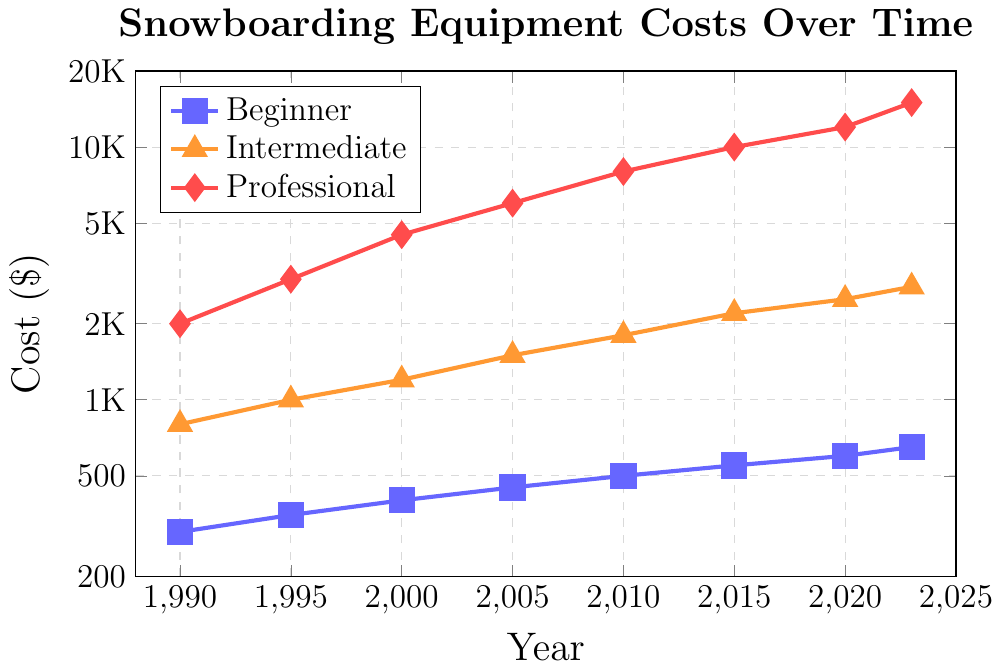What year did professional-grade snowboarding equipment costs first exceed $10,000? Observing the red (Professional) line, the cost first surpasses $10,000 at the point marked "2015".
Answer: 2015 Which level of equipment saw the greatest percentage increase from 1990 to 2023? Calculate the percentage increase for each category:
- Beginner: ((650 - 300) / 300) * 100 = 116.67%
- Intermediate: ((2800 - 800) / 800) * 100 = 250%
- Professional: ((15000 - 2000) / 2000) * 100 = 650%
The professional level saw the greatest percentage increase.
Answer: Professional At which year did the cost of intermediate equipment approximately double compared to its cost in 1990? The 1990 cost for intermediate equipment is $800. Doubling this is $1600. The orange (Intermediate) line reaches $1800 in 2010, which is closest to doubling the 1990 cost.
Answer: 2010 What is the approximate cost difference between beginner and professional equipment in 2023? At 2023, the red (Professional) line is at $15,000 and the blue (Beginner) line is at $650. The difference is $15,000 - $650.
Answer: $14,350 Between which years did intermediate equipment costs see the largest single period increase, and what was the amount of this increase? Observe the orange (Intermediate) line for the largest vertical jump between points:
- 1990 to 1995: $1000 - $800 = $200
- 1995 to 2000: $1200 - $1000 = $200
- 2000 to 2005: $1500 - $1200 = $300
- 2005 to 2010: $1800 - $1500 = $300
- 2010 to 2015: $2200 - $1800 = $400
- 2015 to 2020: $2500 - $2200 = $300
- 2020 to 2023: $2800 - $2500 = $300
The largest increase, $400, occurred between 2010 and 2015.
Answer: 2010 to 2015, $400 What was the rate of increase in the cost of professional equipment per year from 2005 to 2023? Calculate the rate of increase from 2005 ($6000) to 2023 ($15000):
- Duration: 2023 - 2005 = 18 years
- Increase: $15000 - $6000 = $9000
- Rate per year: $9000 / 18 = $500 per year
Answer: $500 per year Which year marks an intermediate cost closest to two-thirds of the professional cost? For each year, calculate two-thirds of the professional cost and find the closest intermediate cost:
- 1990: 2/3 * $2000 = $1333.33 (no closest)
- 1995: 2/3 * $3000 = $2000 (no closest)
- 2000: 2/3 * $4500 = $3000 (no closest)
- 2005: 2/3 * $6000 = $4000 (no closest)
- 2010: 2/3 * $8000 = $5333.33 (no closest)
- 2015: 2/3 * $10000 = $6666.67 (no closest)
- 2020: 2/3 * $12000 = $8000 (no closest)
- 2023: 2/3 * $15000 = $10000 (no closest)
None of the intermediate costs are approximately two-thirds of the professional costs, but the closest consideration might be 1995's $1000 to $3000.
Answer: No exact match, 1995 is closest with $2000 theory vs $1000 